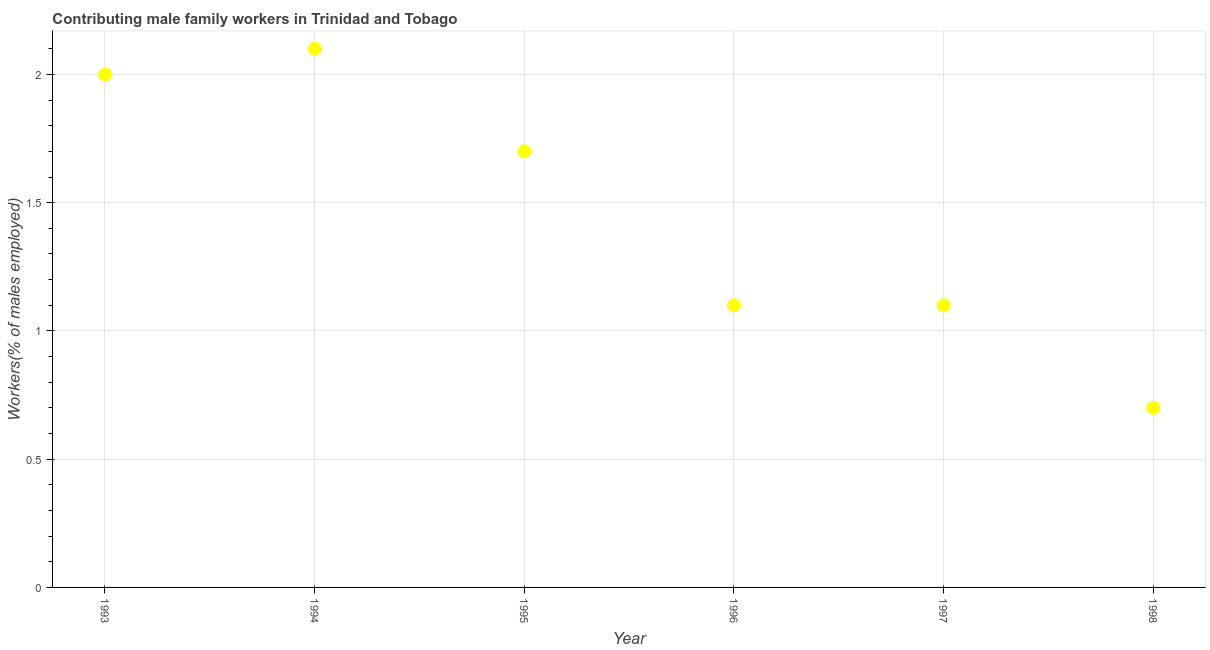What is the contributing male family workers in 1997?
Your response must be concise. 1.1. Across all years, what is the maximum contributing male family workers?
Provide a succinct answer. 2.1. Across all years, what is the minimum contributing male family workers?
Provide a succinct answer. 0.7. In which year was the contributing male family workers minimum?
Provide a succinct answer. 1998. What is the sum of the contributing male family workers?
Give a very brief answer. 8.7. What is the difference between the contributing male family workers in 1993 and 1996?
Your answer should be very brief. 0.9. What is the average contributing male family workers per year?
Offer a very short reply. 1.45. What is the median contributing male family workers?
Your answer should be very brief. 1.4. In how many years, is the contributing male family workers greater than 1 %?
Your answer should be compact. 5. What is the ratio of the contributing male family workers in 1994 to that in 1996?
Your answer should be compact. 1.91. Is the contributing male family workers in 1993 less than that in 1997?
Your answer should be very brief. No. Is the difference between the contributing male family workers in 1993 and 1997 greater than the difference between any two years?
Offer a terse response. No. What is the difference between the highest and the second highest contributing male family workers?
Ensure brevity in your answer.  0.1. What is the difference between the highest and the lowest contributing male family workers?
Offer a terse response. 1.4. How many dotlines are there?
Your answer should be very brief. 1. How many years are there in the graph?
Offer a terse response. 6. Are the values on the major ticks of Y-axis written in scientific E-notation?
Keep it short and to the point. No. Does the graph contain any zero values?
Provide a short and direct response. No. What is the title of the graph?
Offer a terse response. Contributing male family workers in Trinidad and Tobago. What is the label or title of the X-axis?
Give a very brief answer. Year. What is the label or title of the Y-axis?
Give a very brief answer. Workers(% of males employed). What is the Workers(% of males employed) in 1993?
Ensure brevity in your answer.  2. What is the Workers(% of males employed) in 1994?
Offer a very short reply. 2.1. What is the Workers(% of males employed) in 1995?
Your response must be concise. 1.7. What is the Workers(% of males employed) in 1996?
Offer a very short reply. 1.1. What is the Workers(% of males employed) in 1997?
Keep it short and to the point. 1.1. What is the Workers(% of males employed) in 1998?
Provide a short and direct response. 0.7. What is the difference between the Workers(% of males employed) in 1993 and 1994?
Provide a succinct answer. -0.1. What is the difference between the Workers(% of males employed) in 1993 and 1996?
Your answer should be very brief. 0.9. What is the difference between the Workers(% of males employed) in 1993 and 1998?
Your answer should be very brief. 1.3. What is the difference between the Workers(% of males employed) in 1994 and 1995?
Your response must be concise. 0.4. What is the difference between the Workers(% of males employed) in 1994 and 1996?
Make the answer very short. 1. What is the difference between the Workers(% of males employed) in 1994 and 1997?
Provide a short and direct response. 1. What is the difference between the Workers(% of males employed) in 1995 and 1996?
Make the answer very short. 0.6. What is the difference between the Workers(% of males employed) in 1995 and 1997?
Provide a short and direct response. 0.6. What is the difference between the Workers(% of males employed) in 1995 and 1998?
Ensure brevity in your answer.  1. What is the difference between the Workers(% of males employed) in 1997 and 1998?
Provide a short and direct response. 0.4. What is the ratio of the Workers(% of males employed) in 1993 to that in 1995?
Offer a terse response. 1.18. What is the ratio of the Workers(% of males employed) in 1993 to that in 1996?
Give a very brief answer. 1.82. What is the ratio of the Workers(% of males employed) in 1993 to that in 1997?
Offer a terse response. 1.82. What is the ratio of the Workers(% of males employed) in 1993 to that in 1998?
Keep it short and to the point. 2.86. What is the ratio of the Workers(% of males employed) in 1994 to that in 1995?
Keep it short and to the point. 1.24. What is the ratio of the Workers(% of males employed) in 1994 to that in 1996?
Offer a terse response. 1.91. What is the ratio of the Workers(% of males employed) in 1994 to that in 1997?
Your response must be concise. 1.91. What is the ratio of the Workers(% of males employed) in 1994 to that in 1998?
Make the answer very short. 3. What is the ratio of the Workers(% of males employed) in 1995 to that in 1996?
Offer a very short reply. 1.54. What is the ratio of the Workers(% of males employed) in 1995 to that in 1997?
Keep it short and to the point. 1.54. What is the ratio of the Workers(% of males employed) in 1995 to that in 1998?
Ensure brevity in your answer.  2.43. What is the ratio of the Workers(% of males employed) in 1996 to that in 1997?
Offer a very short reply. 1. What is the ratio of the Workers(% of males employed) in 1996 to that in 1998?
Ensure brevity in your answer.  1.57. What is the ratio of the Workers(% of males employed) in 1997 to that in 1998?
Ensure brevity in your answer.  1.57. 